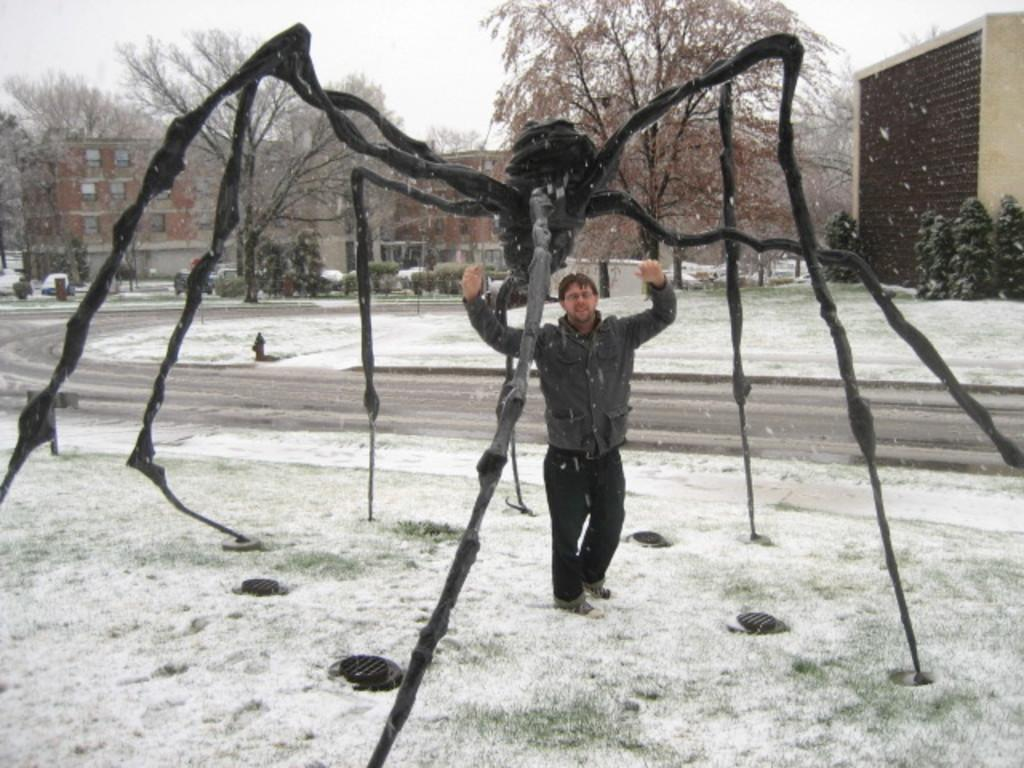What is the main subject of the image? There is a person in the image. What can be seen in the foreground area of the image? There is snow and a model of an insect in the foreground area of the image. What is visible in the background of the image? There are vehicles, trees, buildings, and the sky visible in the background of the image. What type of agreement is being signed by the person in the image? There is no indication of a person signing an agreement in the image. How many sticks are being used by the person in the image? There are no sticks present in the image. 